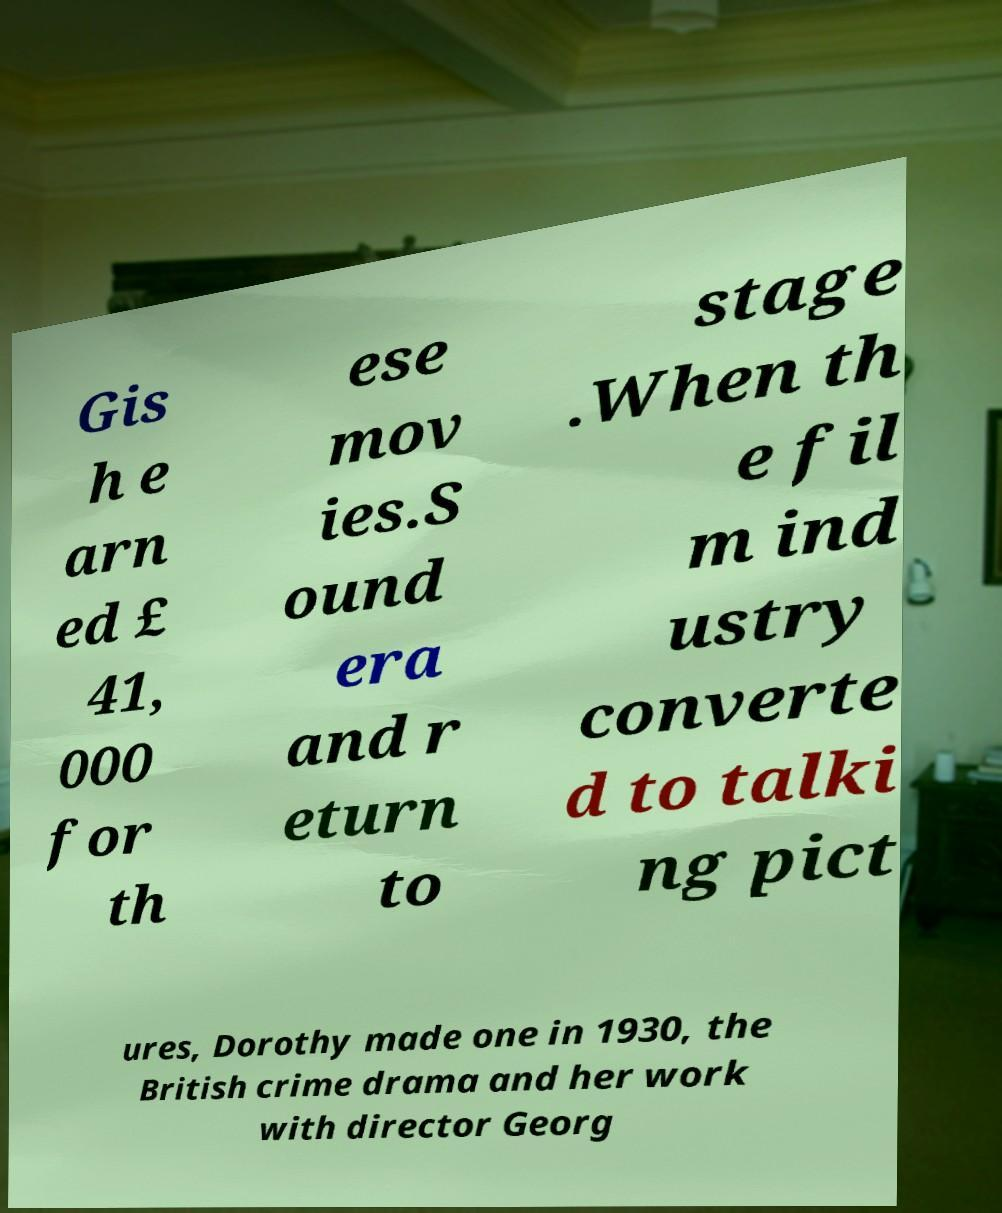I need the written content from this picture converted into text. Can you do that? Gis h e arn ed £ 41, 000 for th ese mov ies.S ound era and r eturn to stage .When th e fil m ind ustry converte d to talki ng pict ures, Dorothy made one in 1930, the British crime drama and her work with director Georg 